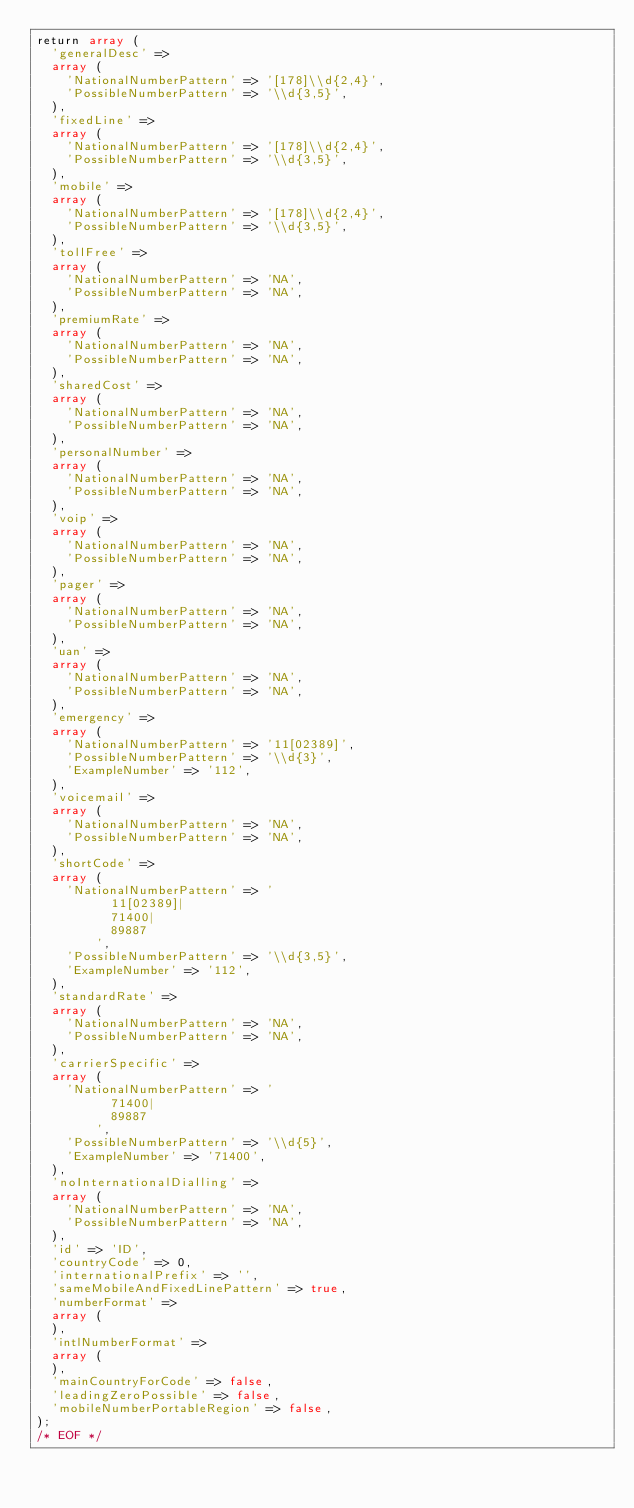Convert code to text. <code><loc_0><loc_0><loc_500><loc_500><_PHP_>return array (
  'generalDesc' => 
  array (
    'NationalNumberPattern' => '[178]\\d{2,4}',
    'PossibleNumberPattern' => '\\d{3,5}',
  ),
  'fixedLine' => 
  array (
    'NationalNumberPattern' => '[178]\\d{2,4}',
    'PossibleNumberPattern' => '\\d{3,5}',
  ),
  'mobile' => 
  array (
    'NationalNumberPattern' => '[178]\\d{2,4}',
    'PossibleNumberPattern' => '\\d{3,5}',
  ),
  'tollFree' => 
  array (
    'NationalNumberPattern' => 'NA',
    'PossibleNumberPattern' => 'NA',
  ),
  'premiumRate' => 
  array (
    'NationalNumberPattern' => 'NA',
    'PossibleNumberPattern' => 'NA',
  ),
  'sharedCost' => 
  array (
    'NationalNumberPattern' => 'NA',
    'PossibleNumberPattern' => 'NA',
  ),
  'personalNumber' => 
  array (
    'NationalNumberPattern' => 'NA',
    'PossibleNumberPattern' => 'NA',
  ),
  'voip' => 
  array (
    'NationalNumberPattern' => 'NA',
    'PossibleNumberPattern' => 'NA',
  ),
  'pager' => 
  array (
    'NationalNumberPattern' => 'NA',
    'PossibleNumberPattern' => 'NA',
  ),
  'uan' => 
  array (
    'NationalNumberPattern' => 'NA',
    'PossibleNumberPattern' => 'NA',
  ),
  'emergency' => 
  array (
    'NationalNumberPattern' => '11[02389]',
    'PossibleNumberPattern' => '\\d{3}',
    'ExampleNumber' => '112',
  ),
  'voicemail' => 
  array (
    'NationalNumberPattern' => 'NA',
    'PossibleNumberPattern' => 'NA',
  ),
  'shortCode' => 
  array (
    'NationalNumberPattern' => '
          11[02389]|
          71400|
          89887
        ',
    'PossibleNumberPattern' => '\\d{3,5}',
    'ExampleNumber' => '112',
  ),
  'standardRate' => 
  array (
    'NationalNumberPattern' => 'NA',
    'PossibleNumberPattern' => 'NA',
  ),
  'carrierSpecific' => 
  array (
    'NationalNumberPattern' => '
          71400|
          89887
        ',
    'PossibleNumberPattern' => '\\d{5}',
    'ExampleNumber' => '71400',
  ),
  'noInternationalDialling' => 
  array (
    'NationalNumberPattern' => 'NA',
    'PossibleNumberPattern' => 'NA',
  ),
  'id' => 'ID',
  'countryCode' => 0,
  'internationalPrefix' => '',
  'sameMobileAndFixedLinePattern' => true,
  'numberFormat' => 
  array (
  ),
  'intlNumberFormat' => 
  array (
  ),
  'mainCountryForCode' => false,
  'leadingZeroPossible' => false,
  'mobileNumberPortableRegion' => false,
);
/* EOF */</code> 